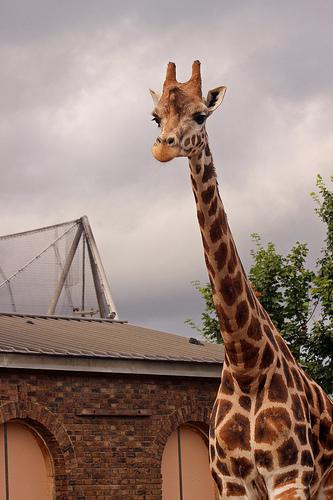Question: what is the buildings bottom made of?
Choices:
A. Stone.
B. Concrete.
C. Plaster.
D. Brick.
Answer with the letter. Answer: D Question: how many animals?
Choices:
A. Three.
B. One.
C. Five.
D. Six.
Answer with the letter. Answer: B Question: when was this taken?
Choices:
A. During the night.
B. During the day.
C. In the morning.
D. In the afternoon.
Answer with the letter. Answer: B Question: where is the tin?
Choices:
A. On the badge.
B. On roof.
C. Cup.
D. Knife handle.
Answer with the letter. Answer: B Question: what is standing?
Choices:
A. A table.
B. An animal.
C. A building.
D. A telephone pole.
Answer with the letter. Answer: B 